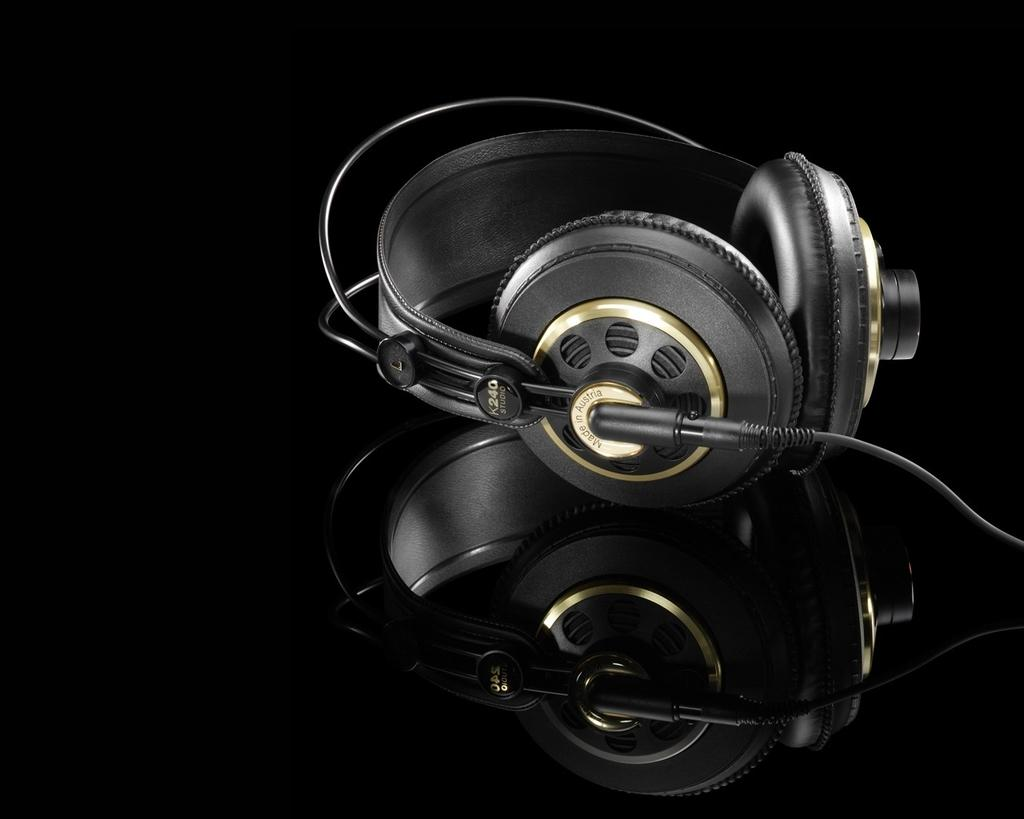What is the main object in the image? There is a headphone in the image. On what surface is the headphone placed? The headphone is on a glass table. Where was the image taken? The image was taken in a room. What type of ornament is hanging from the headphone in the image? There is no ornament hanging from the headphone in the image. How does the headphone contribute to the society in the image? The image does not depict any societal context, so it is not possible to determine how the headphone contributes to society. 